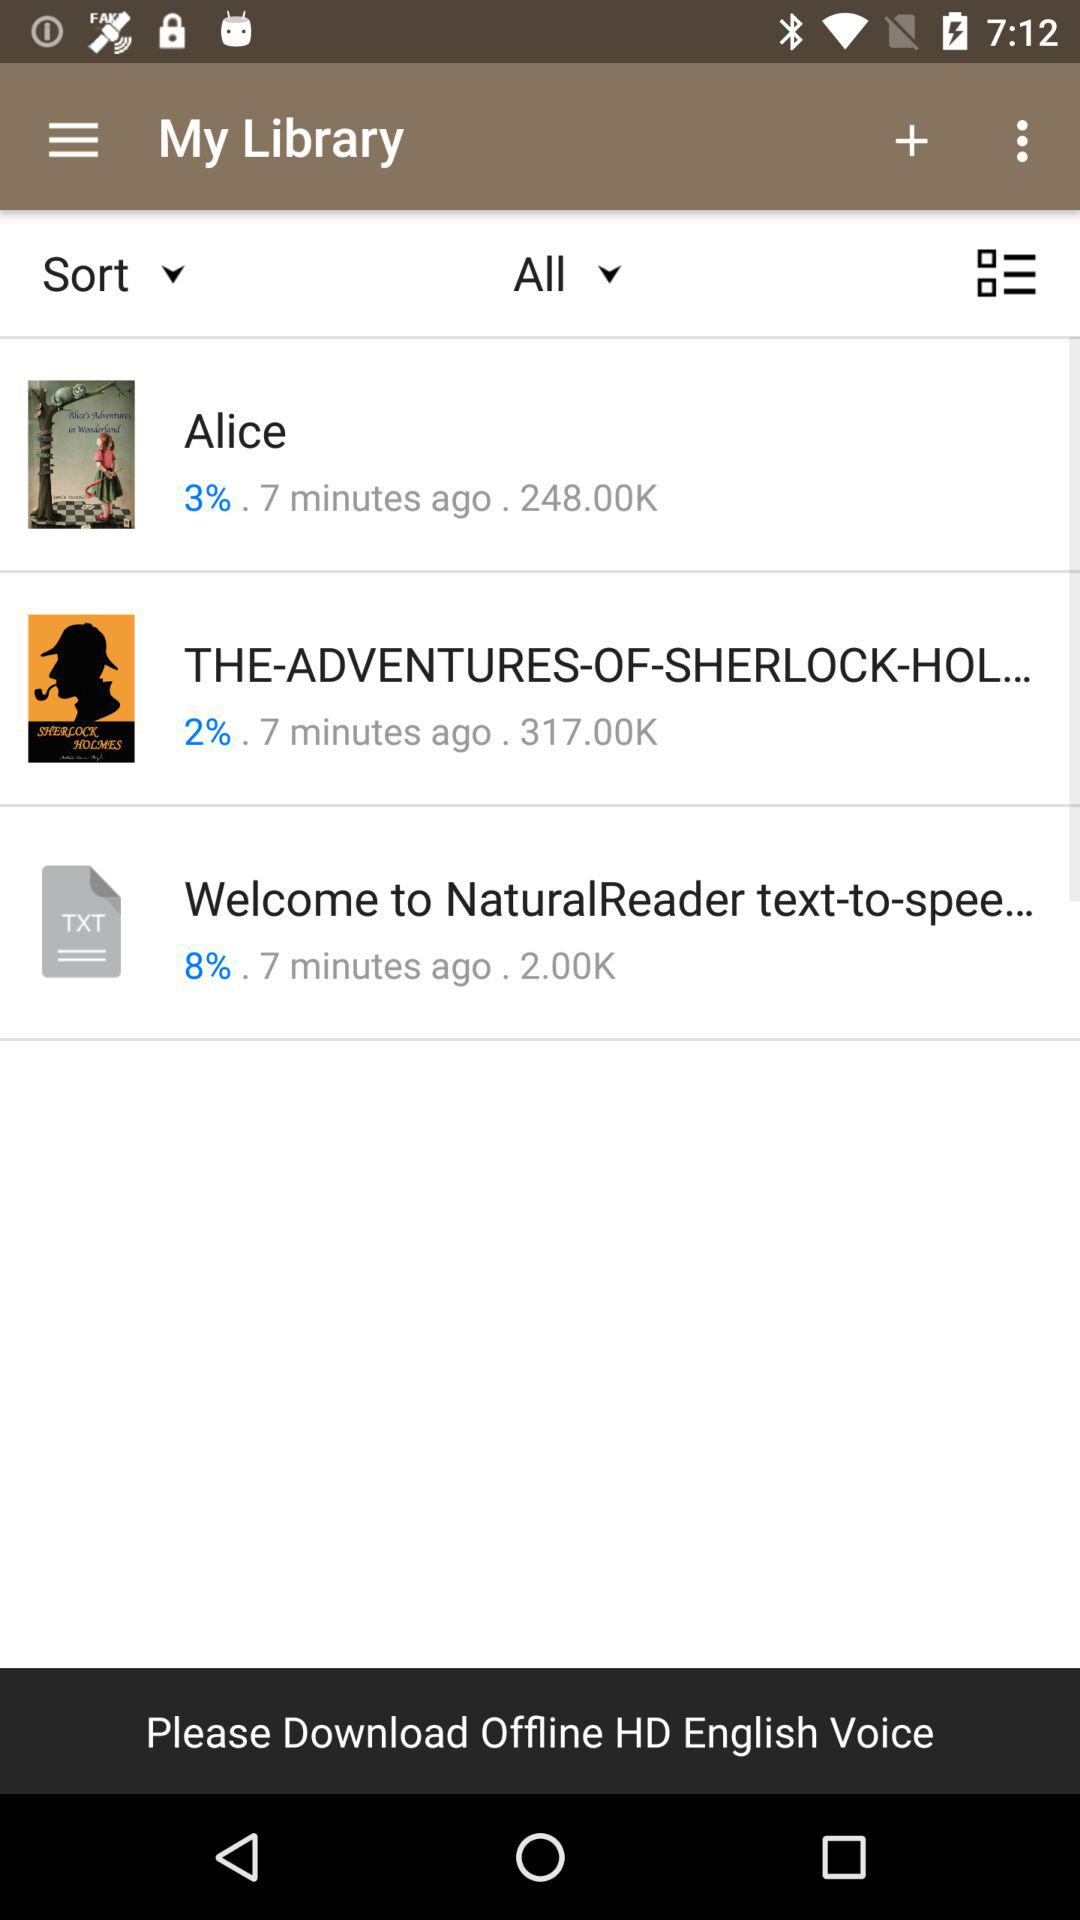When did "THE-ADVENTURES-OF-SHERLOCK-HOLMES" begin to download? "THE-ADVENTURES-OF-SHERLOCK-HOLMES" began to download 7 minutes ago. 